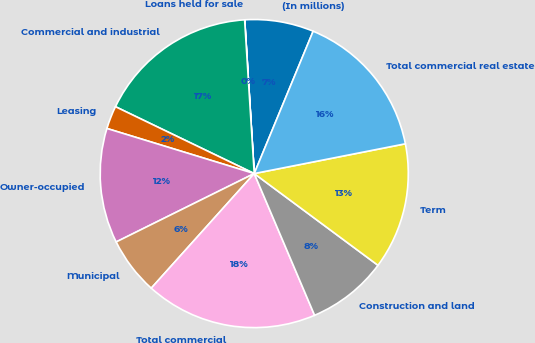<chart> <loc_0><loc_0><loc_500><loc_500><pie_chart><fcel>(In millions)<fcel>Loans held for sale<fcel>Commercial and industrial<fcel>Leasing<fcel>Owner-occupied<fcel>Municipal<fcel>Total commercial<fcel>Construction and land<fcel>Term<fcel>Total commercial real estate<nl><fcel>7.23%<fcel>0.01%<fcel>16.86%<fcel>2.42%<fcel>12.05%<fcel>6.03%<fcel>18.06%<fcel>8.44%<fcel>13.25%<fcel>15.66%<nl></chart> 